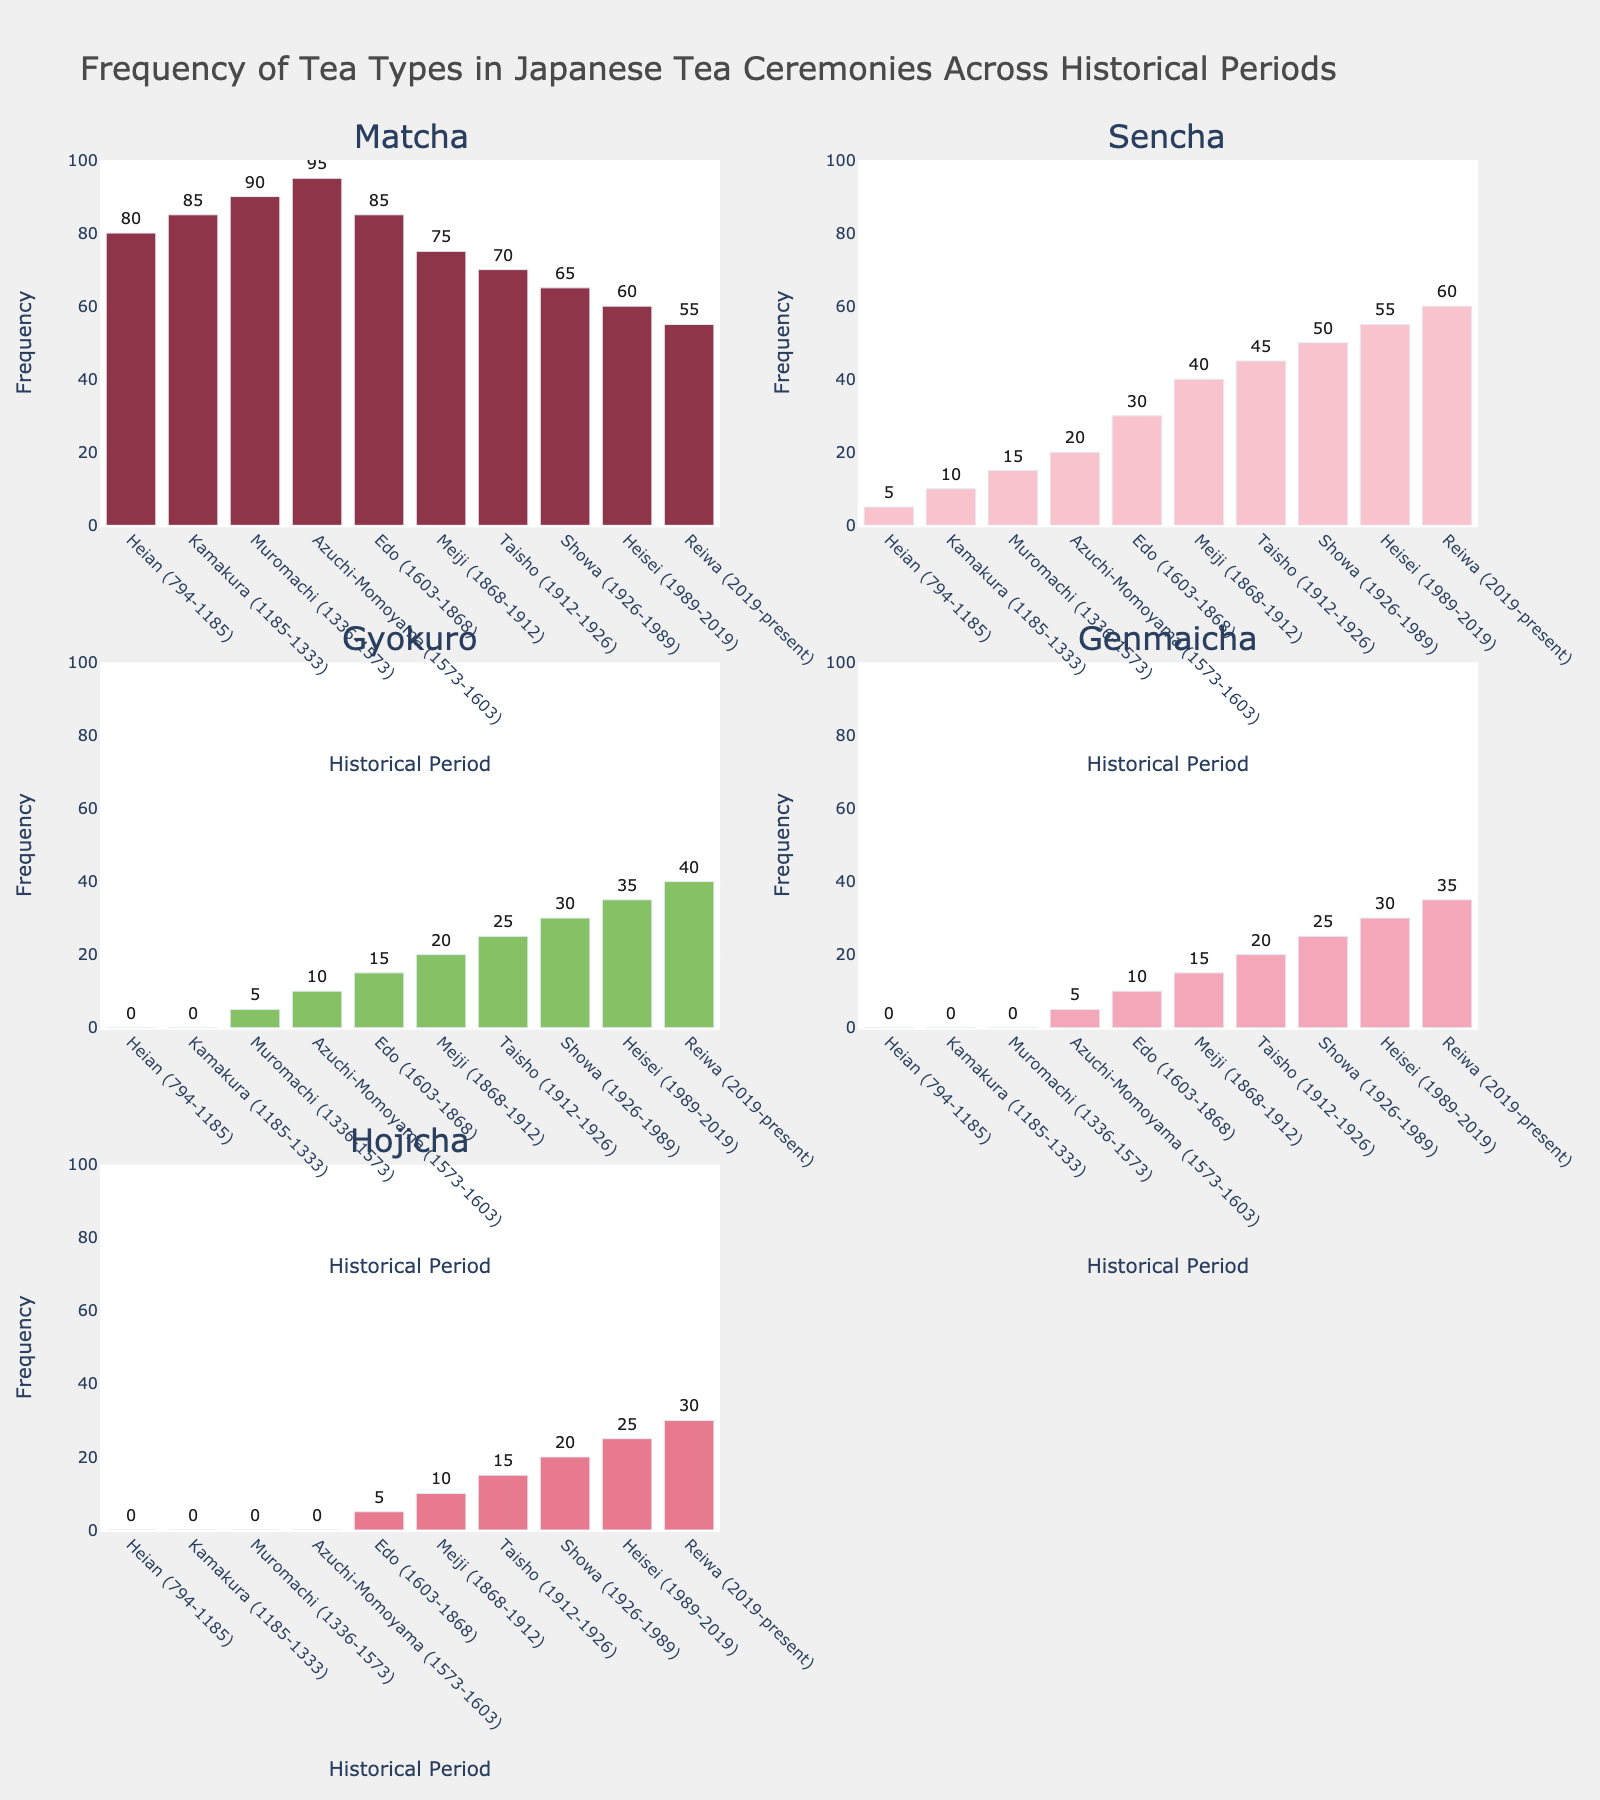what is the most frequent tea type during the Heian period? By looking at the height of the bars for the Heian period, the Matcha bar is the tallest, indicating that Matcha is the most frequent tea type during this period.
Answer: Matcha During which period did Sencha overtake Matcha in frequency? By examining the periods where Sencha's bar height surpasses Matcha's, it becomes clear that in the Reiwa period, Sencha overtakes Matcha in frequency.
Answer: Reiwa How does the frequency of Gyokuro in the Edo period compare to its frequency in the Taisho period? The heights of the Gyokuro bars indicate that Gyokuro's frequency in the Edo period (15) is less than in the Taisho period (25).
Answer: less Calculate the difference in frequency of Genmaicha between the Azuchi-Momoyama and Heisei periods. The frequency of Genmaicha in the Azuchi-Momoyama period is 5, and in the Heisei period is 30. The difference is calculated as 30 - 5.
Answer: 25 What's the average frequency of Hojicha in the periods where it is present? The periods where Hojicha is present include Edo (5), Meiji (10), Taisho (15), Showa (20), Heisei (25), and Reiwa (30). Calculating the average: (5 + 10 + 15 + 20 + 25 + 30) / 6 = 105 / 6 = 17.5
Answer: 17.5 Which tea type showed a declining trend in frequency from the Showa to Reiwa period? Observing the bars from the Showa to Reiwa period, Matcha shows a declining trend in frequency.
Answer: Matcha What is the total frequency of all tea types in the Meiji period? Summing the heights of all tea type bars in the Meiji period: Matcha (75), Sencha (40), Gyokuro (20), Genmaicha (15), Hojicha (10). Total = 75 + 40 + 20 + 15 + 10 = 160.
Answer: 160 Which period marks the introduction of Hojicha? The Hojicha bar first appears in the Edo period.
Answer: Edo 